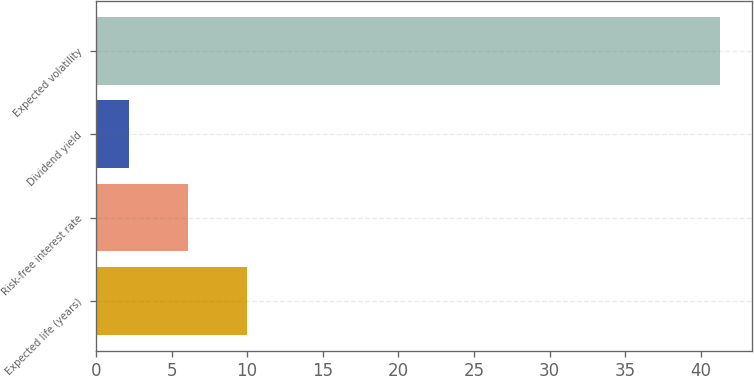<chart> <loc_0><loc_0><loc_500><loc_500><bar_chart><fcel>Expected life (years)<fcel>Risk-free interest rate<fcel>Dividend yield<fcel>Expected volatility<nl><fcel>10.02<fcel>6.11<fcel>2.2<fcel>41.3<nl></chart> 